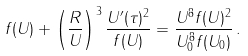<formula> <loc_0><loc_0><loc_500><loc_500>f ( U ) + \left ( \frac { R } { U } \right ) ^ { 3 } \frac { U ^ { \prime } ( \tau ) ^ { 2 } } { f ( U ) } = \frac { U ^ { 8 } f ( U ) ^ { 2 } } { U _ { 0 } ^ { 8 } f ( U _ { 0 } ) } \, .</formula> 